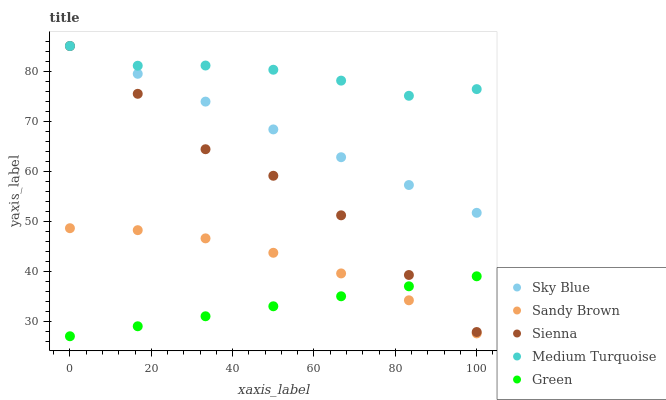Does Green have the minimum area under the curve?
Answer yes or no. Yes. Does Medium Turquoise have the maximum area under the curve?
Answer yes or no. Yes. Does Sky Blue have the minimum area under the curve?
Answer yes or no. No. Does Sky Blue have the maximum area under the curve?
Answer yes or no. No. Is Green the smoothest?
Answer yes or no. Yes. Is Sienna the roughest?
Answer yes or no. Yes. Is Sky Blue the smoothest?
Answer yes or no. No. Is Sky Blue the roughest?
Answer yes or no. No. Does Green have the lowest value?
Answer yes or no. Yes. Does Sky Blue have the lowest value?
Answer yes or no. No. Does Medium Turquoise have the highest value?
Answer yes or no. Yes. Does Green have the highest value?
Answer yes or no. No. Is Green less than Sky Blue?
Answer yes or no. Yes. Is Sky Blue greater than Sandy Brown?
Answer yes or no. Yes. Does Sky Blue intersect Medium Turquoise?
Answer yes or no. Yes. Is Sky Blue less than Medium Turquoise?
Answer yes or no. No. Is Sky Blue greater than Medium Turquoise?
Answer yes or no. No. Does Green intersect Sky Blue?
Answer yes or no. No. 